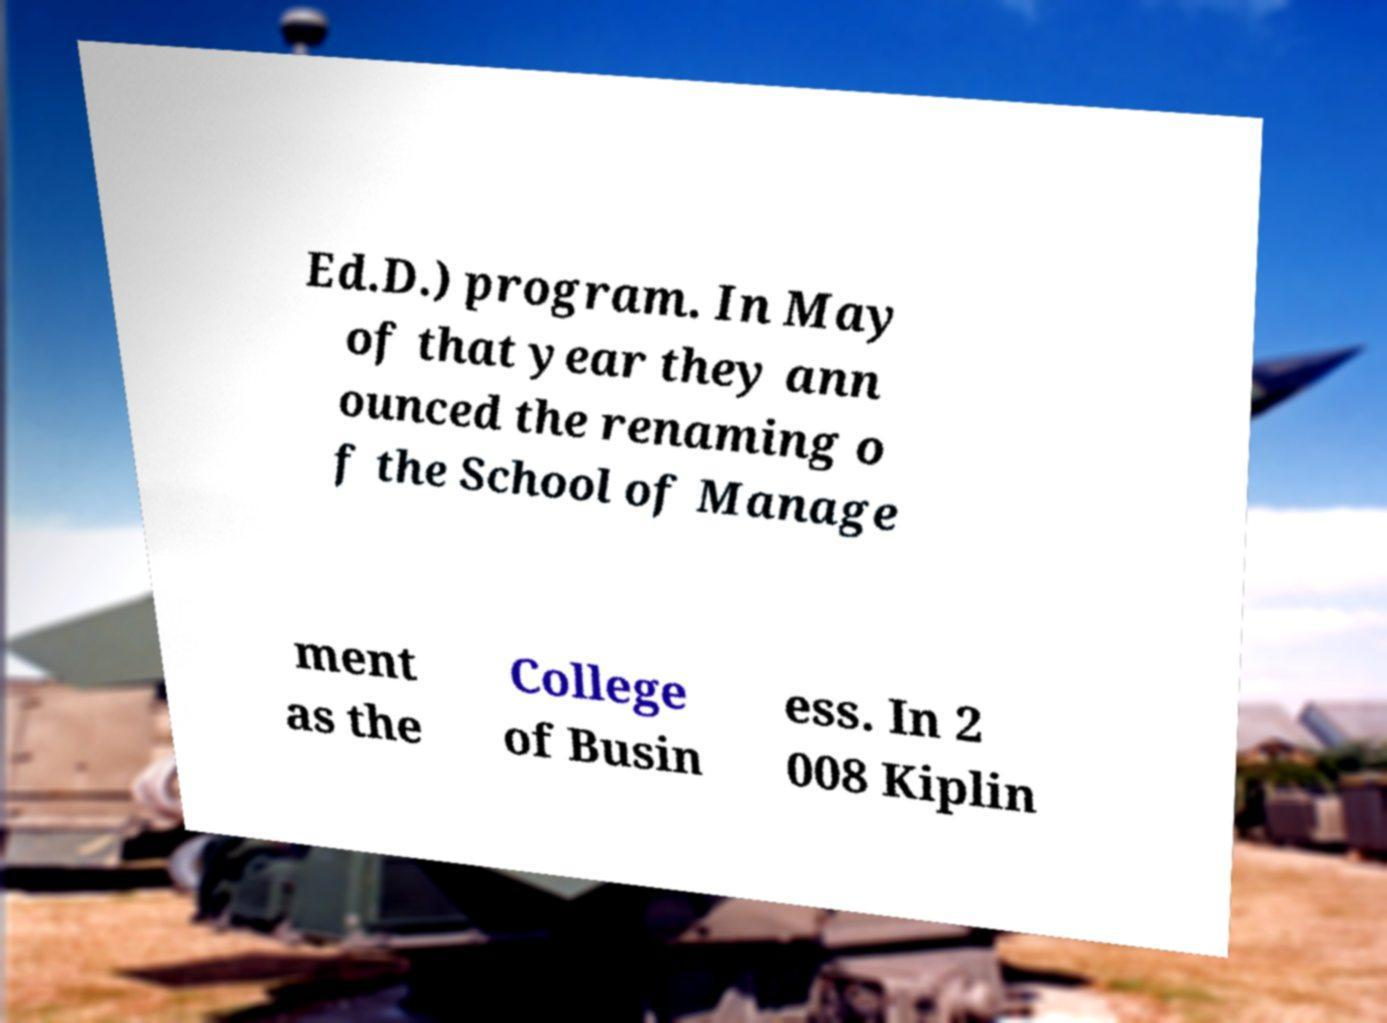Can you read and provide the text displayed in the image?This photo seems to have some interesting text. Can you extract and type it out for me? Ed.D.) program. In May of that year they ann ounced the renaming o f the School of Manage ment as the College of Busin ess. In 2 008 Kiplin 